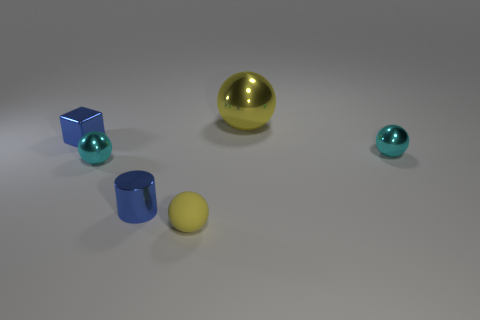Are there an equal number of big yellow objects that are left of the tiny blue shiny cylinder and tiny blue shiny blocks that are to the right of the block? After carefully analyzing the image, it appears there is one big yellow sphere to the left of the tiny blue shiny cylinder. To the right of the blue block, there is one tiny blue shiny sphere. So yes, there is an equal number of specified objects in the described locations. 